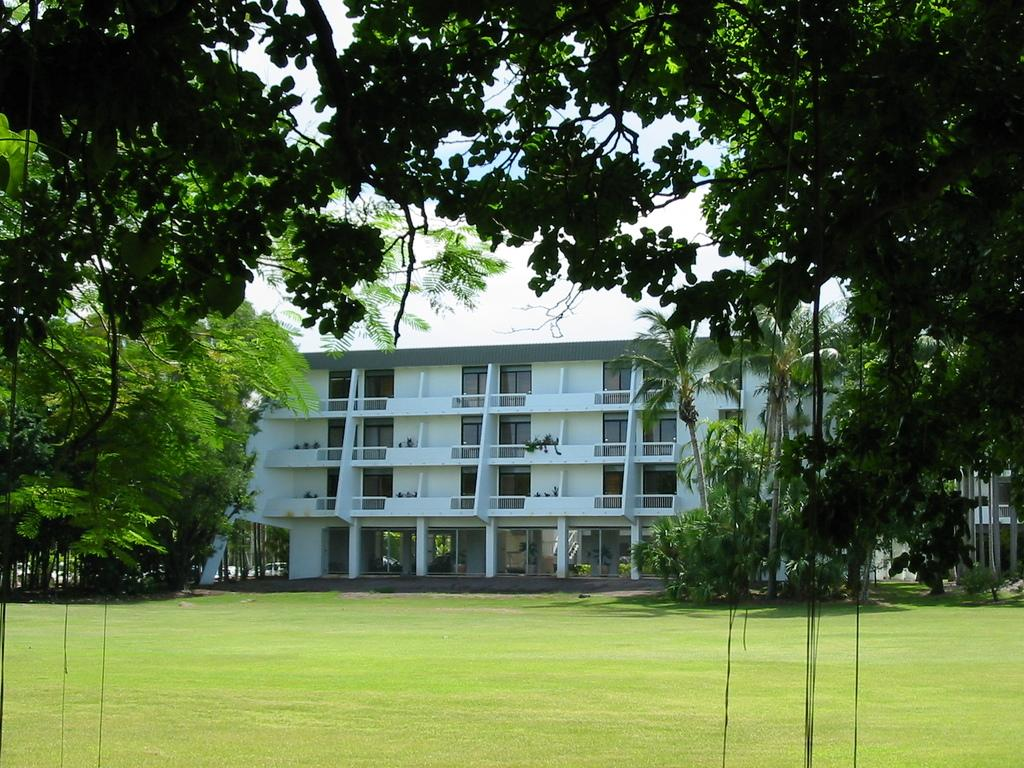What type of structure is present in the image? There is a building in the image. Can you describe the color of the building? The building is white. What other natural elements can be seen in the image? There are trees in the image. What is the color of the trees? The trees are green. What part of the natural environment is visible in the image? The sky is visible in the image. What is the color of the sky? The sky is white. How many bears can be seen playing in the image? There are no bears present in the image. 